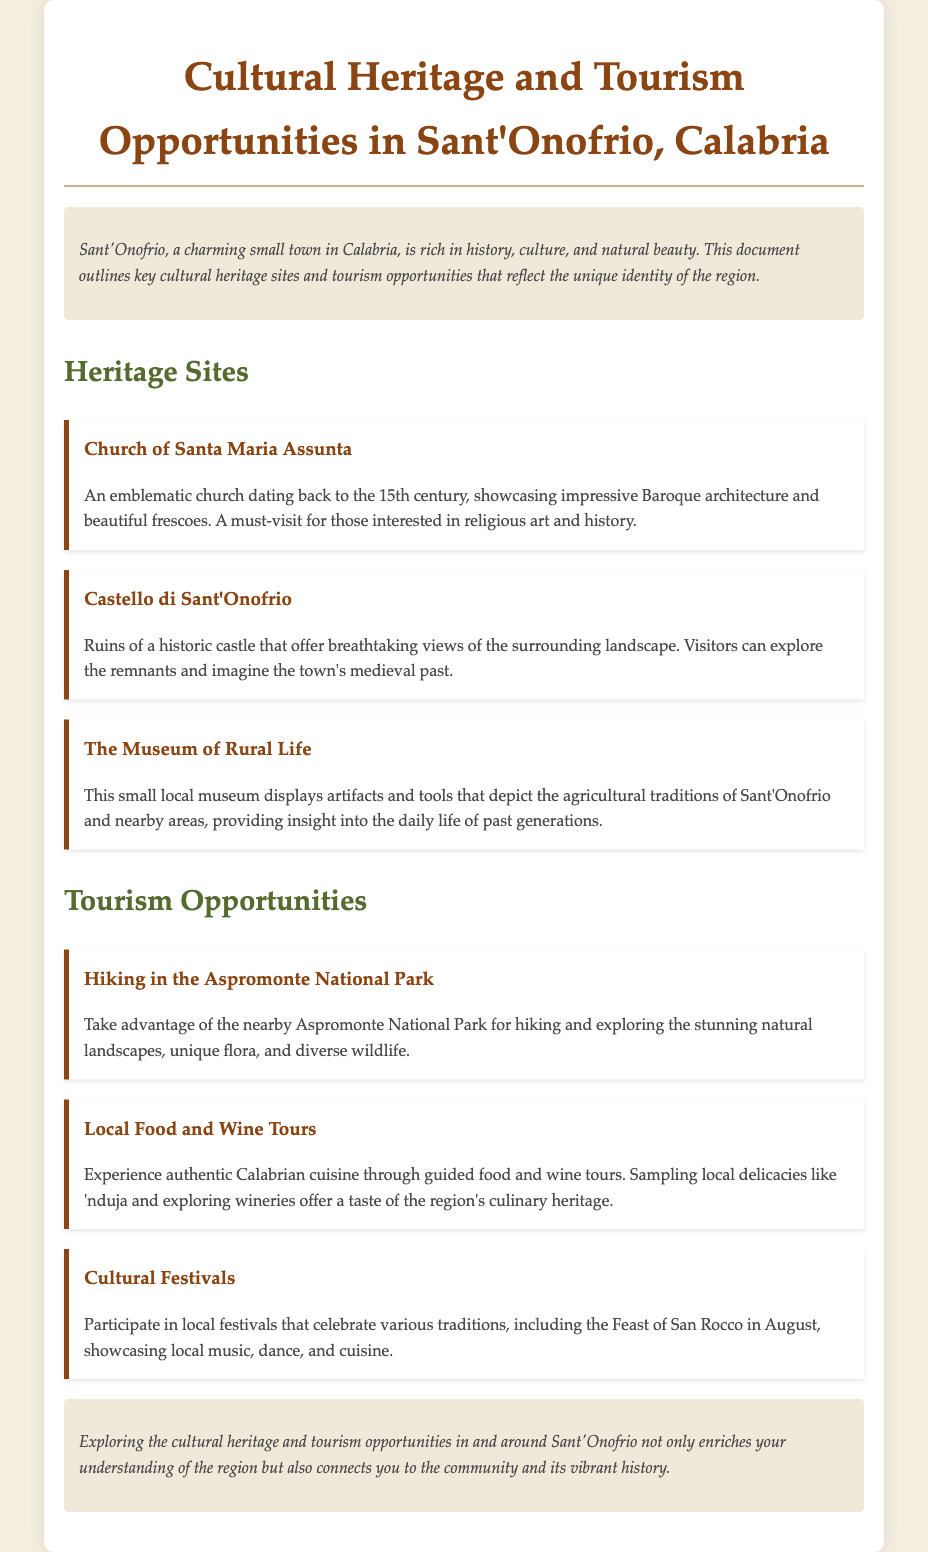What is the name of the church mentioned? The church mentioned is "Church of Santa Maria Assunta."
Answer: Church of Santa Maria Assunta In which century was the Church of Santa Maria Assunta built? The document states that the Church dates back to the 15th century.
Answer: 15th century What type of architecture does the Church of Santa Maria Assunta showcase? The church exemplifies impressive Baroque architecture.
Answer: Baroque What natural location is mentioned for hiking? The document references the "Aspromonte National Park" for hiking opportunities.
Answer: Aspromonte National Park What local dish is highlighted in the food tours? The document mentions "nduja" as a local delicacy to sample.
Answer: 'nduja Which festival is celebrated in August? The Feast of San Rocco is celebrated in August as per the document.
Answer: Feast of San Rocco What is the purpose of the Museum of Rural Life? The museum displays artifacts that depict the agricultural traditions of the region.
Answer: Agricultural traditions How many heritage sites are listed in the document? The document lists three heritage sites related to cultural heritage in Sant'Onofrio.
Answer: Three What type of tourism opportunity focuses on local cuisine? The opportunity mentioned is "Local Food and Wine Tours" which focuses on local cuisine.
Answer: Local Food and Wine Tours 